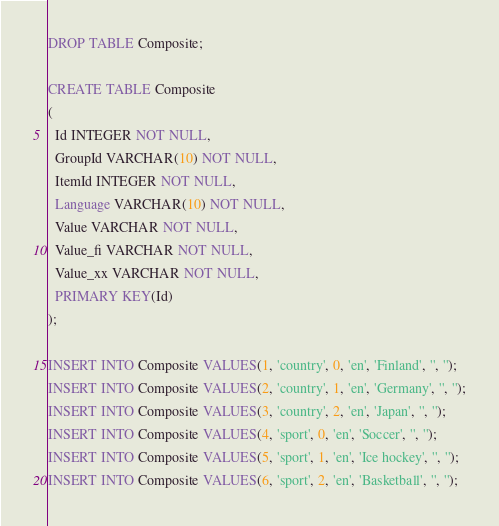Convert code to text. <code><loc_0><loc_0><loc_500><loc_500><_SQL_>DROP TABLE Composite;

CREATE TABLE Composite
(
  Id INTEGER NOT NULL,
  GroupId VARCHAR(10) NOT NULL,
  ItemId INTEGER NOT NULL,
  Language VARCHAR(10) NOT NULL,
  Value VARCHAR NOT NULL,
  Value_fi VARCHAR NOT NULL,
  Value_xx VARCHAR NOT NULL,
  PRIMARY KEY(Id)
);

INSERT INTO Composite VALUES(1, 'country', 0, 'en', 'Finland', '', '');
INSERT INTO Composite VALUES(2, 'country', 1, 'en', 'Germany', '', '');
INSERT INTO Composite VALUES(3, 'country', 2, 'en', 'Japan', '', '');
INSERT INTO Composite VALUES(4, 'sport', 0, 'en', 'Soccer', '', '');
INSERT INTO Composite VALUES(5, 'sport', 1, 'en', 'Ice hockey', '', '');
INSERT INTO Composite VALUES(6, 'sport', 2, 'en', 'Basketball', '', '');
</code> 